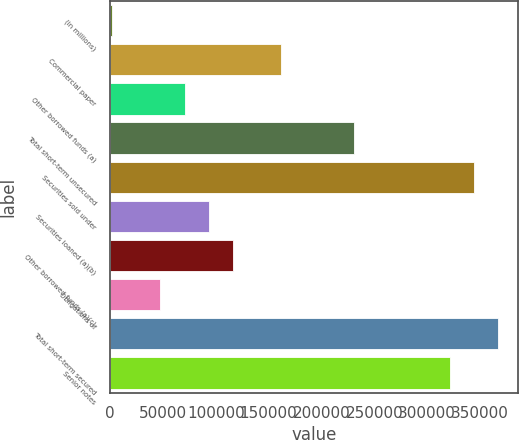<chart> <loc_0><loc_0><loc_500><loc_500><bar_chart><fcel>(in millions)<fcel>Commercial paper<fcel>Other borrowed funds (a)<fcel>Total short-term unsecured<fcel>Securities sold under<fcel>Securities loaned (a)(b)<fcel>Other borrowed funds (a)(c)<fcel>Obligations of<fcel>Total short-term secured<fcel>Senior notes<nl><fcel>2017<fcel>161850<fcel>70516.9<fcel>230350<fcel>344516<fcel>93350.2<fcel>116184<fcel>47683.6<fcel>367350<fcel>321683<nl></chart> 